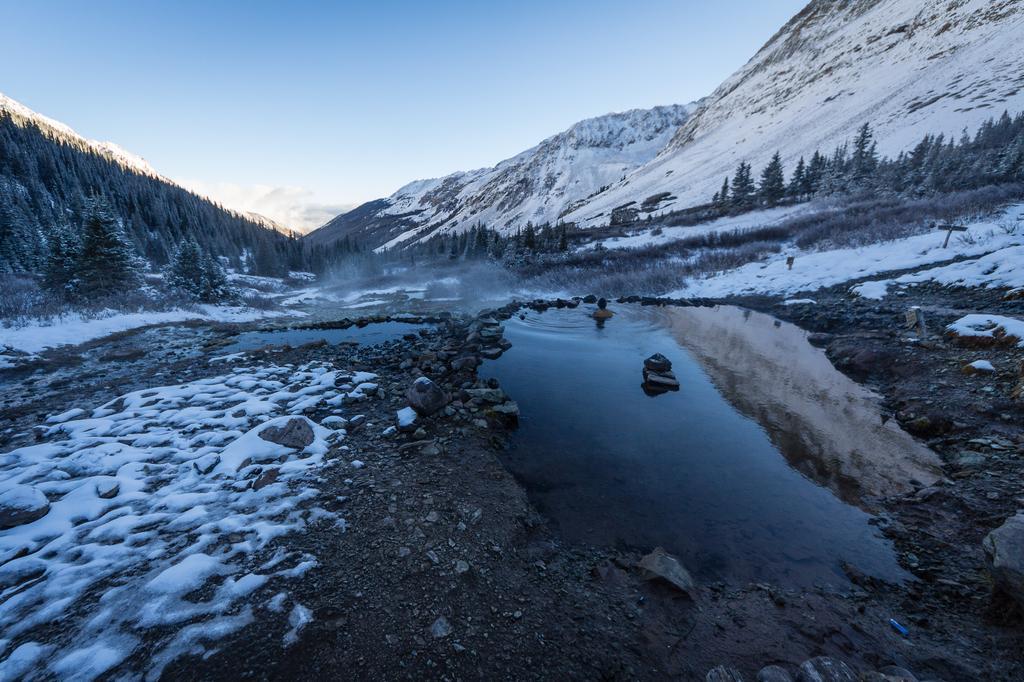Describe this image in one or two sentences. In this image, we can see a pond. There are some trees and mountains in the middle of the image. There is a sky at the top of the image. 